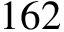<formula> <loc_0><loc_0><loc_500><loc_500>1 6 2</formula> 